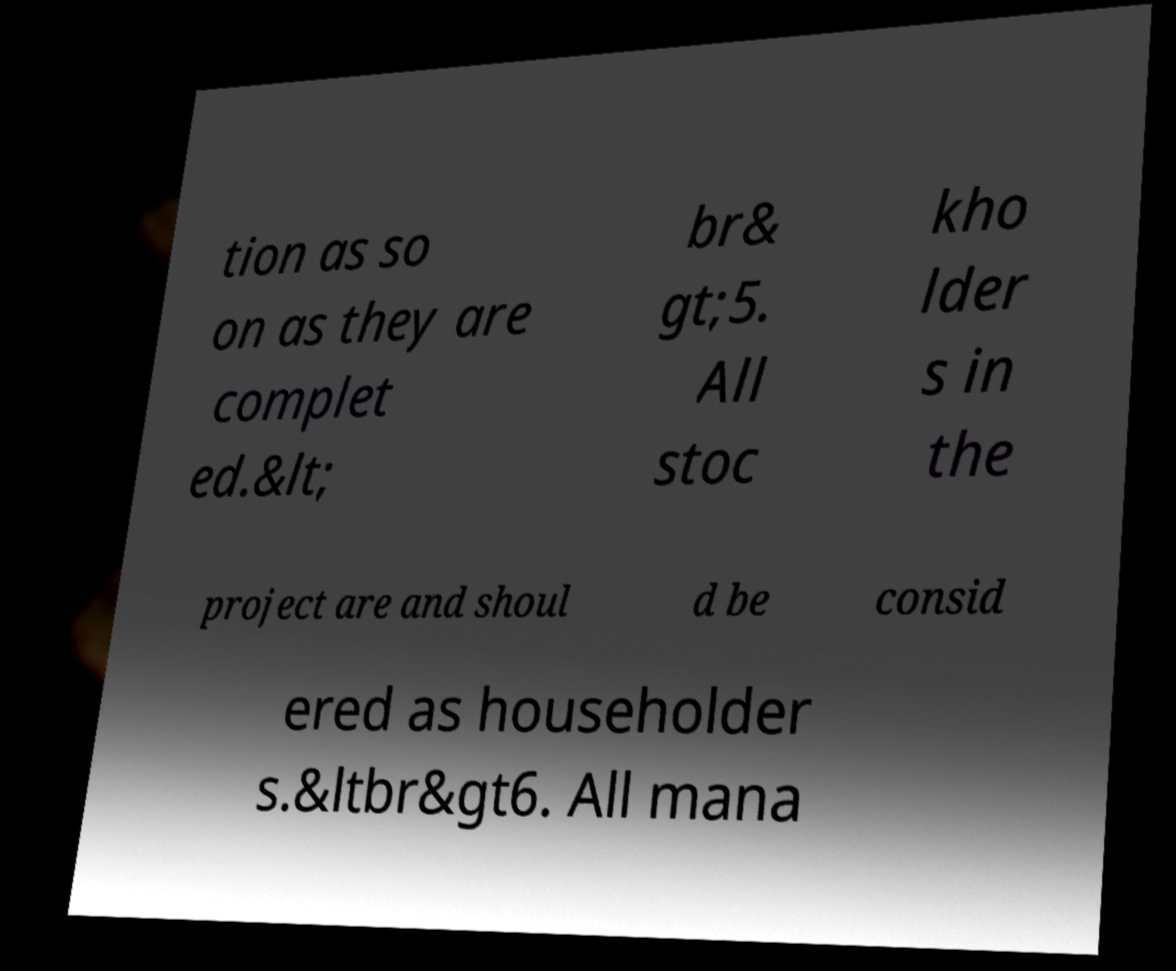What messages or text are displayed in this image? I need them in a readable, typed format. tion as so on as they are complet ed.&lt; br& gt;5. All stoc kho lder s in the project are and shoul d be consid ered as householder s.&ltbr&gt6. All mana 